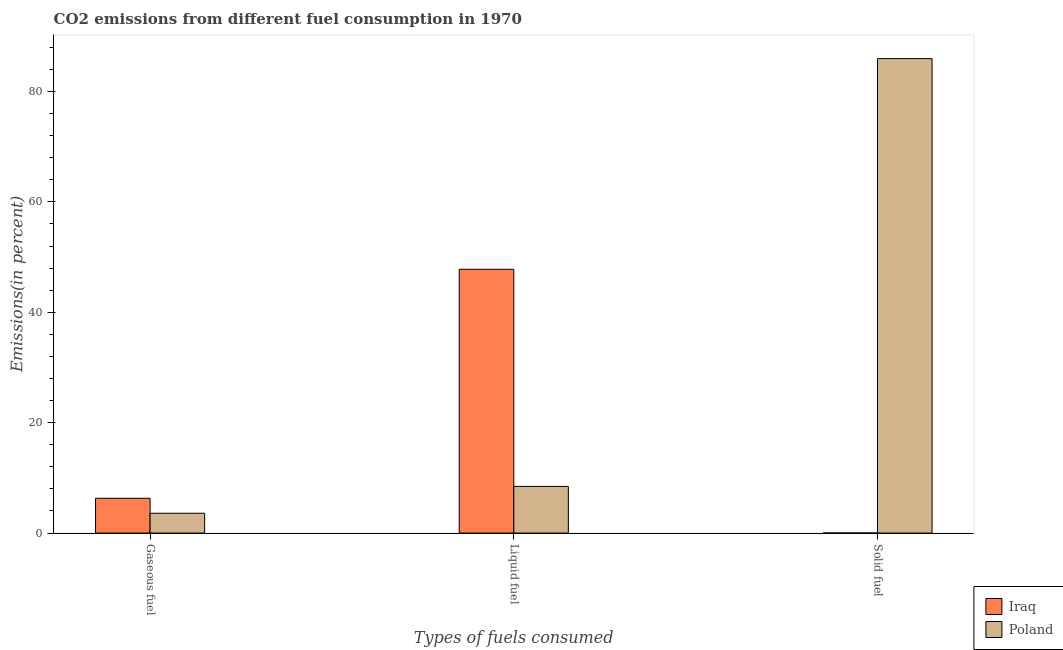How many groups of bars are there?
Provide a short and direct response. 3. Are the number of bars per tick equal to the number of legend labels?
Provide a short and direct response. Yes. What is the label of the 3rd group of bars from the left?
Make the answer very short. Solid fuel. What is the percentage of solid fuel emission in Poland?
Make the answer very short. 85.96. Across all countries, what is the maximum percentage of gaseous fuel emission?
Give a very brief answer. 6.3. Across all countries, what is the minimum percentage of liquid fuel emission?
Offer a very short reply. 8.46. In which country was the percentage of liquid fuel emission maximum?
Offer a terse response. Iraq. What is the total percentage of solid fuel emission in the graph?
Offer a terse response. 85.98. What is the difference between the percentage of solid fuel emission in Poland and that in Iraq?
Ensure brevity in your answer.  85.95. What is the difference between the percentage of liquid fuel emission in Poland and the percentage of solid fuel emission in Iraq?
Ensure brevity in your answer.  8.44. What is the average percentage of gaseous fuel emission per country?
Your response must be concise. 4.95. What is the difference between the percentage of liquid fuel emission and percentage of solid fuel emission in Poland?
Your response must be concise. -77.5. What is the ratio of the percentage of gaseous fuel emission in Poland to that in Iraq?
Keep it short and to the point. 0.57. Is the percentage of gaseous fuel emission in Iraq less than that in Poland?
Your answer should be compact. No. What is the difference between the highest and the second highest percentage of gaseous fuel emission?
Your response must be concise. 2.72. What is the difference between the highest and the lowest percentage of solid fuel emission?
Your response must be concise. 85.95. In how many countries, is the percentage of gaseous fuel emission greater than the average percentage of gaseous fuel emission taken over all countries?
Provide a succinct answer. 1. What does the 2nd bar from the left in Gaseous fuel represents?
Ensure brevity in your answer.  Poland. What does the 2nd bar from the right in Gaseous fuel represents?
Make the answer very short. Iraq. How many bars are there?
Make the answer very short. 6. How many countries are there in the graph?
Provide a short and direct response. 2. What is the difference between two consecutive major ticks on the Y-axis?
Offer a very short reply. 20. Does the graph contain any zero values?
Provide a short and direct response. No. Does the graph contain grids?
Keep it short and to the point. No. How are the legend labels stacked?
Provide a short and direct response. Vertical. What is the title of the graph?
Make the answer very short. CO2 emissions from different fuel consumption in 1970. Does "Korea (Democratic)" appear as one of the legend labels in the graph?
Ensure brevity in your answer.  No. What is the label or title of the X-axis?
Keep it short and to the point. Types of fuels consumed. What is the label or title of the Y-axis?
Make the answer very short. Emissions(in percent). What is the Emissions(in percent) in Iraq in Gaseous fuel?
Offer a very short reply. 6.3. What is the Emissions(in percent) in Poland in Gaseous fuel?
Your answer should be very brief. 3.59. What is the Emissions(in percent) in Iraq in Liquid fuel?
Make the answer very short. 47.79. What is the Emissions(in percent) in Poland in Liquid fuel?
Make the answer very short. 8.46. What is the Emissions(in percent) of Iraq in Solid fuel?
Provide a succinct answer. 0.02. What is the Emissions(in percent) in Poland in Solid fuel?
Offer a very short reply. 85.96. Across all Types of fuels consumed, what is the maximum Emissions(in percent) of Iraq?
Provide a succinct answer. 47.79. Across all Types of fuels consumed, what is the maximum Emissions(in percent) in Poland?
Your answer should be compact. 85.96. Across all Types of fuels consumed, what is the minimum Emissions(in percent) of Iraq?
Keep it short and to the point. 0.02. Across all Types of fuels consumed, what is the minimum Emissions(in percent) in Poland?
Ensure brevity in your answer.  3.59. What is the total Emissions(in percent) of Iraq in the graph?
Your answer should be very brief. 54.11. What is the total Emissions(in percent) in Poland in the graph?
Your response must be concise. 98. What is the difference between the Emissions(in percent) in Iraq in Gaseous fuel and that in Liquid fuel?
Make the answer very short. -41.49. What is the difference between the Emissions(in percent) of Poland in Gaseous fuel and that in Liquid fuel?
Give a very brief answer. -4.87. What is the difference between the Emissions(in percent) of Iraq in Gaseous fuel and that in Solid fuel?
Provide a short and direct response. 6.29. What is the difference between the Emissions(in percent) in Poland in Gaseous fuel and that in Solid fuel?
Your response must be concise. -82.37. What is the difference between the Emissions(in percent) in Iraq in Liquid fuel and that in Solid fuel?
Make the answer very short. 47.78. What is the difference between the Emissions(in percent) in Poland in Liquid fuel and that in Solid fuel?
Provide a short and direct response. -77.5. What is the difference between the Emissions(in percent) in Iraq in Gaseous fuel and the Emissions(in percent) in Poland in Liquid fuel?
Keep it short and to the point. -2.15. What is the difference between the Emissions(in percent) of Iraq in Gaseous fuel and the Emissions(in percent) of Poland in Solid fuel?
Provide a short and direct response. -79.66. What is the difference between the Emissions(in percent) in Iraq in Liquid fuel and the Emissions(in percent) in Poland in Solid fuel?
Your answer should be compact. -38.17. What is the average Emissions(in percent) in Iraq per Types of fuels consumed?
Provide a short and direct response. 18.04. What is the average Emissions(in percent) in Poland per Types of fuels consumed?
Your answer should be very brief. 32.67. What is the difference between the Emissions(in percent) in Iraq and Emissions(in percent) in Poland in Gaseous fuel?
Your response must be concise. 2.72. What is the difference between the Emissions(in percent) in Iraq and Emissions(in percent) in Poland in Liquid fuel?
Offer a very short reply. 39.34. What is the difference between the Emissions(in percent) of Iraq and Emissions(in percent) of Poland in Solid fuel?
Give a very brief answer. -85.94. What is the ratio of the Emissions(in percent) in Iraq in Gaseous fuel to that in Liquid fuel?
Provide a succinct answer. 0.13. What is the ratio of the Emissions(in percent) of Poland in Gaseous fuel to that in Liquid fuel?
Ensure brevity in your answer.  0.42. What is the ratio of the Emissions(in percent) in Iraq in Gaseous fuel to that in Solid fuel?
Give a very brief answer. 411. What is the ratio of the Emissions(in percent) of Poland in Gaseous fuel to that in Solid fuel?
Your response must be concise. 0.04. What is the ratio of the Emissions(in percent) of Iraq in Liquid fuel to that in Solid fuel?
Provide a short and direct response. 3116. What is the ratio of the Emissions(in percent) in Poland in Liquid fuel to that in Solid fuel?
Make the answer very short. 0.1. What is the difference between the highest and the second highest Emissions(in percent) of Iraq?
Offer a very short reply. 41.49. What is the difference between the highest and the second highest Emissions(in percent) in Poland?
Ensure brevity in your answer.  77.5. What is the difference between the highest and the lowest Emissions(in percent) of Iraq?
Offer a very short reply. 47.78. What is the difference between the highest and the lowest Emissions(in percent) in Poland?
Provide a short and direct response. 82.37. 